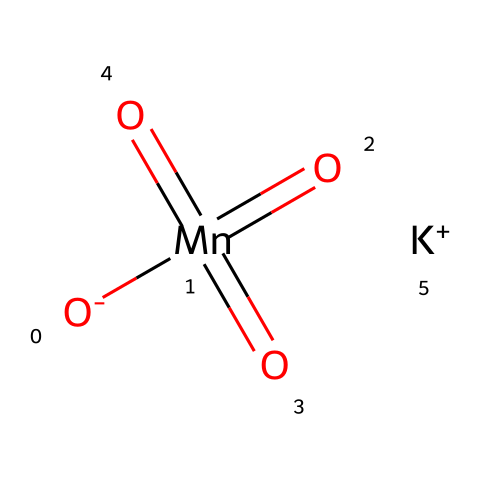What is the central metal atom in this molecule? The SMILES representation indicates the presence of "Mn" which denotes the manganese atom, and it is located at the center of the structure.
Answer: manganese How many oxygen atoms are present in potassium permanganate? The SMILES representation shows four oxygen atoms ("O"). Counting them, we find that there are four oxygen atoms connected to the manganese atom in the chemical structure.
Answer: four What is the oxidation state of manganese in this compound? Manganese typically has an oxidation state of +7 in permanganate, deduced from its connections in the oxidation states usually associated with potassium permanganate.
Answer: +7 What type of compound is potassium permanganate classified as? The presence of manganese and oxygen in this molecular structure suggests that it is an oxidizing agent, as permanganate is known for its strong oxidizing properties in various chemical reactions.
Answer: oxidizer What is the charge on the potassium ion in this molecule? The symbol "[K+]" in the SMILES signifies that the potassium ion has a positive charge (+1), identified by the "+" sign.
Answer: +1 Describe the type of bonding in potassium permanganate. The presence of manganese, oxygen, and potassium indicates ionic bonding between potassium and the permanganate polyatomic ion (MnO4-) due to the electrostatic attraction between the positively charged potassium ion and the negatively charged permanganate ion.
Answer: ionic bonding How many distinct types of bonds are found in the molecular structure? In potassium permanganate, there are both ionic bonds (between K+ and MnO4-) and covalent bonds (between Mn and O), making it necessary to count both types. Thus, there are two distinct types of bonds.
Answer: two 